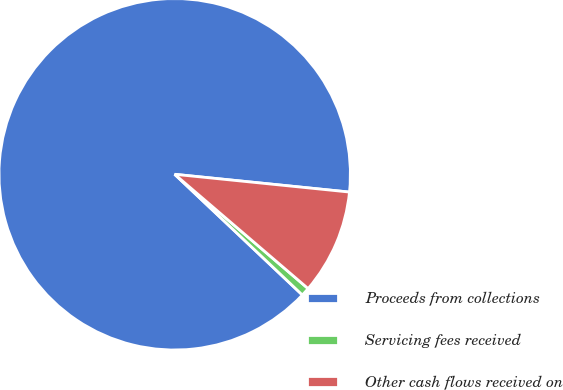<chart> <loc_0><loc_0><loc_500><loc_500><pie_chart><fcel>Proceeds from collections<fcel>Servicing fees received<fcel>Other cash flows received on<nl><fcel>89.56%<fcel>0.78%<fcel>9.66%<nl></chart> 